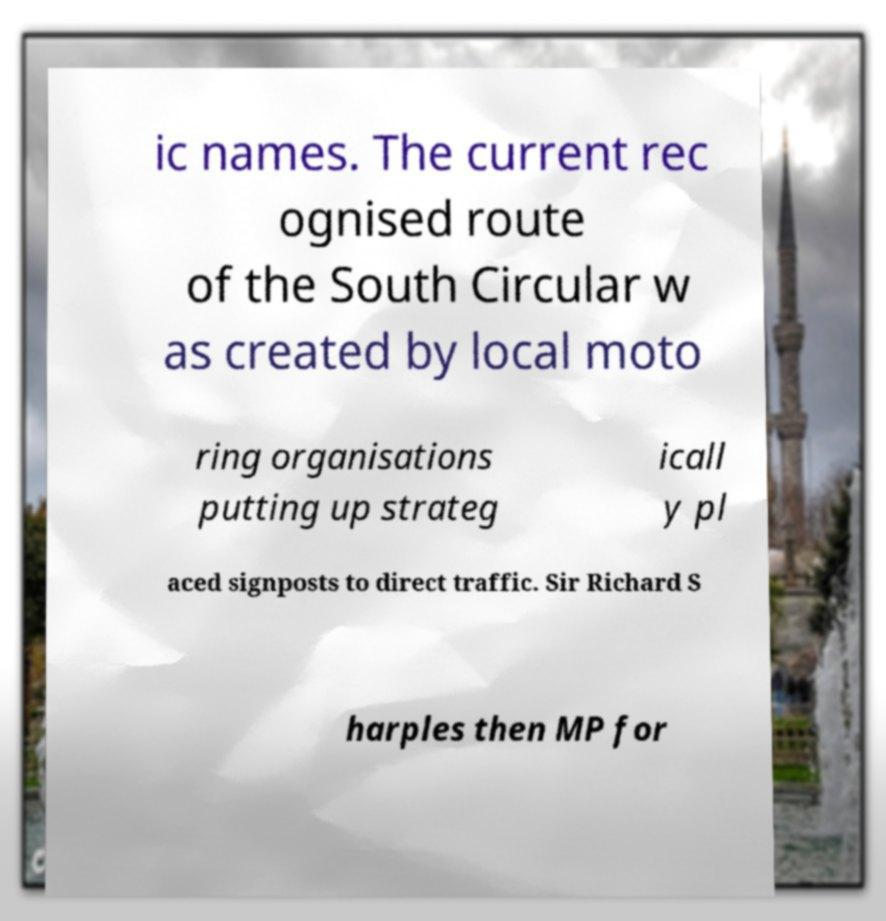For documentation purposes, I need the text within this image transcribed. Could you provide that? ic names. The current rec ognised route of the South Circular w as created by local moto ring organisations putting up strateg icall y pl aced signposts to direct traffic. Sir Richard S harples then MP for 